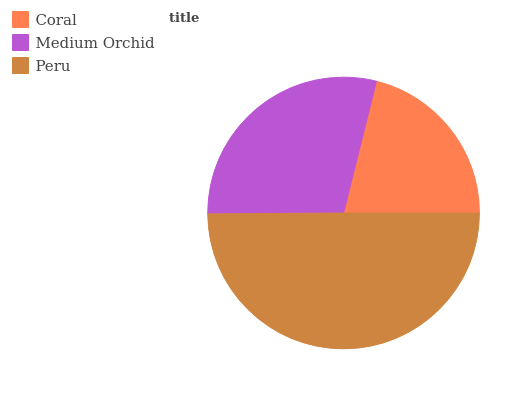Is Coral the minimum?
Answer yes or no. Yes. Is Peru the maximum?
Answer yes or no. Yes. Is Medium Orchid the minimum?
Answer yes or no. No. Is Medium Orchid the maximum?
Answer yes or no. No. Is Medium Orchid greater than Coral?
Answer yes or no. Yes. Is Coral less than Medium Orchid?
Answer yes or no. Yes. Is Coral greater than Medium Orchid?
Answer yes or no. No. Is Medium Orchid less than Coral?
Answer yes or no. No. Is Medium Orchid the high median?
Answer yes or no. Yes. Is Medium Orchid the low median?
Answer yes or no. Yes. Is Peru the high median?
Answer yes or no. No. Is Peru the low median?
Answer yes or no. No. 